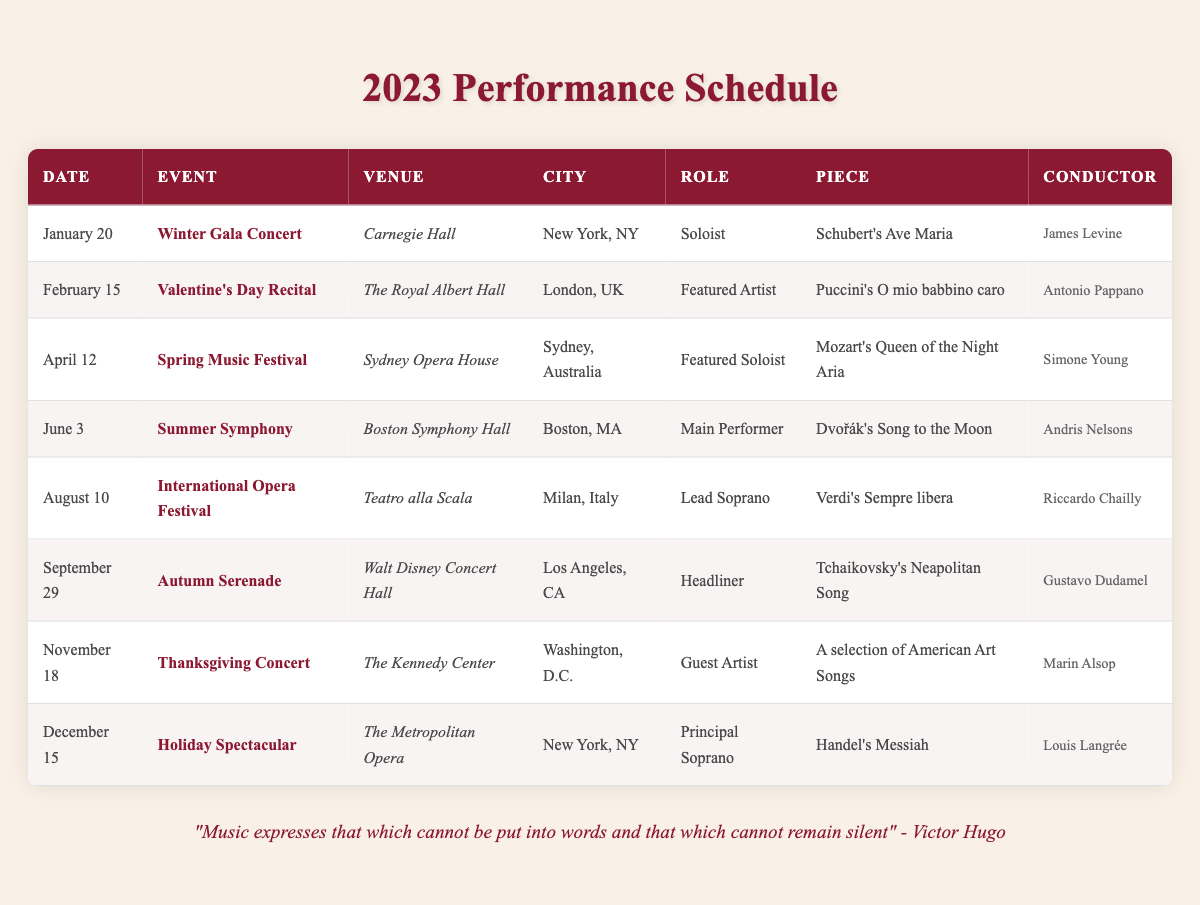What is the date of the Winter Gala Concert? The table lists the event "Winter Gala Concert" under the date column, which shows "January 20".
Answer: January 20 Which piece will be performed at the Thanksgiving Concert? The Thanksgiving Concert is listed in the table. The corresponding piece performs is "A selection of American Art Songs".
Answer: A selection of American Art Songs How many performances are scheduled in New York, NY? By counting the entries in the table that indicate "New York, NY" in the city column, there are two events: 'Winter Gala Concert' and 'Holiday Spectacular'.
Answer: 2 Who is conducting the Summer Symphony? The Summer Symphony event in the table shows 'Andris Nelsons' listed as the conductor.
Answer: Andris Nelsons What role does the soprano singer have at the International Opera Festival? The event "International Opera Festival" in the table indicates the role is "Lead Soprano".
Answer: Lead Soprano Which event is scheduled right before the Holiday Spectacular? The table shows that the event before "Holiday Spectacular" is "Thanksgiving Concert" on November 18.
Answer: Thanksgiving Concert How many events are taking place outside the United States? The table lists three events taking place outside the United States: "Valentine’s Day Recital" in London, "Spring Music Festival" in Sydney, and "International Opera Festival" in Milan.
Answer: 3 What is the role of the singer in the Autumn Serenade? The table specifies the role for the "Autumn Serenade" event as "Headliner".
Answer: Headliner Which conductor is associated with the piece "Mozart's Queen of the Night Aria"? The "Spring Music Festival" event where "Mozart's Queen of the Night Aria" is performed has "Simone Young" as the conductor according to the table.
Answer: Simone Young What is the average number of performances per quarter in 2023? There are eight performances throughout the year, and four quarters, so dividing gives an average of 8 / 4 = 2 performances per quarter.
Answer: 2 Is the soprano singer performing at both Carnegie Hall and The Metropolitan Opera in 2023? Checking the table, the soprano singer is performing at "Winter Gala Concert" in Carnegie Hall and "Holiday Spectacular" in The Metropolitan Opera; therefore, the statement is true.
Answer: Yes Which event in 2023 occurs in the summer? By looking at the dates, "Summer Symphony" on June 3 is the performance that occurs in the summer season.
Answer: Summer Symphony What are the names of the pieces performed at events in August and September? The piece performed in August at the "International Opera Festival" is "Verdi's Sempre libera" and in September at the "Autumn Serenade" is "Tchaikovsky's Neapolitan Song".
Answer: Verdi's Sempre libera and Tchaikovsky's Neapolitan Song How many roles listed are associated with being a "Soloist"? In the table, "Soloist" appears once in the "Winter Gala Concert". Therefore, there's only one associated role listed as "Soloist".
Answer: 1 What is the last event of the year? The table indicates that the last event scheduled for 2023 is "Holiday Spectacular" on December 15.
Answer: Holiday Spectacular 